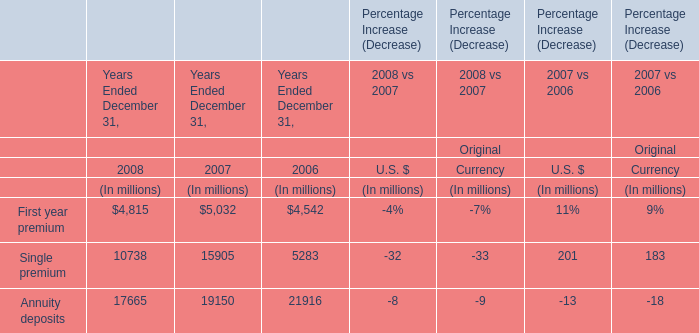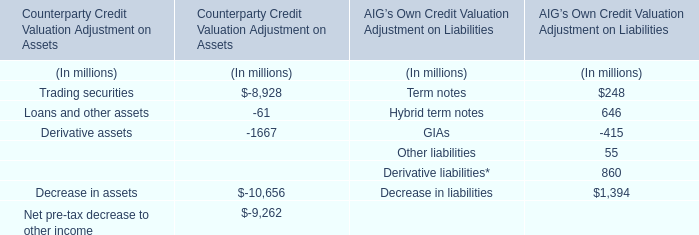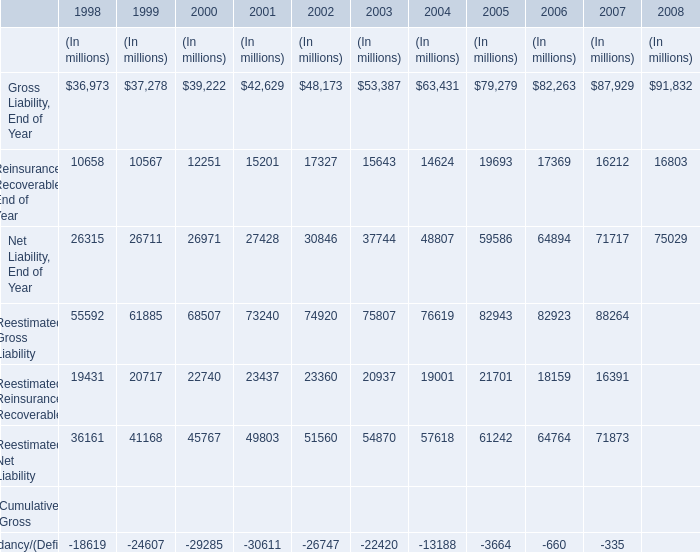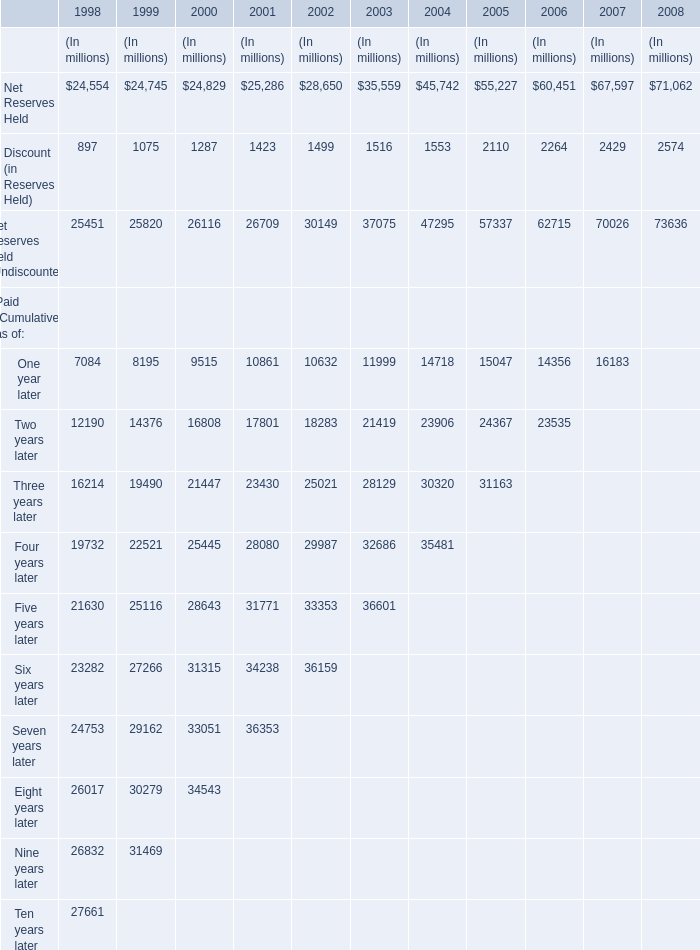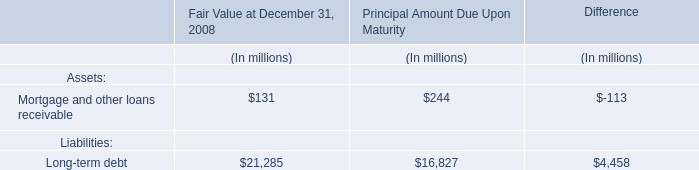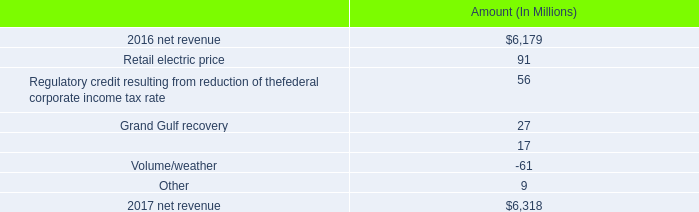What will Gross Liability be like in 2009 if it continues to grow at the same rate as it did in 2008? (in million) 
Computations: ((((91832 - 87929) / 87929) + 1) * 91832)
Answer: 95908.2467. 